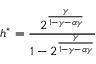Convert formula to latex. <formula><loc_0><loc_0><loc_500><loc_500>h ^ { * } = \frac { 2 ^ { \frac { \gamma } { 1 - \gamma - \alpha \gamma } } } { 1 - 2 ^ { \frac { \gamma } { 1 - \gamma - \alpha \gamma } } }</formula> 